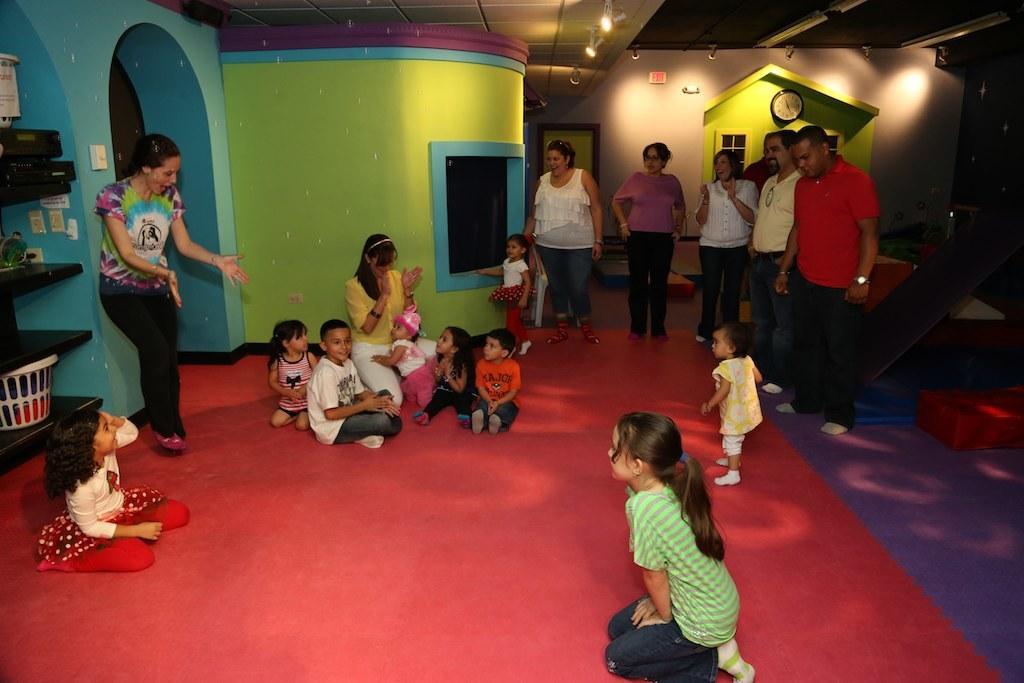How would you summarize this image in a sentence or two? In this picture we can see a few kids are sitting on a red carpet. Some people are standing on the carpet. There is a basket and other objects on the shelves. We can see a wall clock at the back. There are some lights on top. 